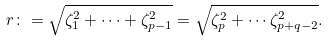<formula> <loc_0><loc_0><loc_500><loc_500>r \colon = \sqrt { \zeta _ { 1 } ^ { 2 } + \cdots + \zeta _ { p - 1 } ^ { 2 } } = \sqrt { \zeta _ { p } ^ { 2 } + \cdots \zeta _ { p + q - 2 } ^ { 2 } } .</formula> 